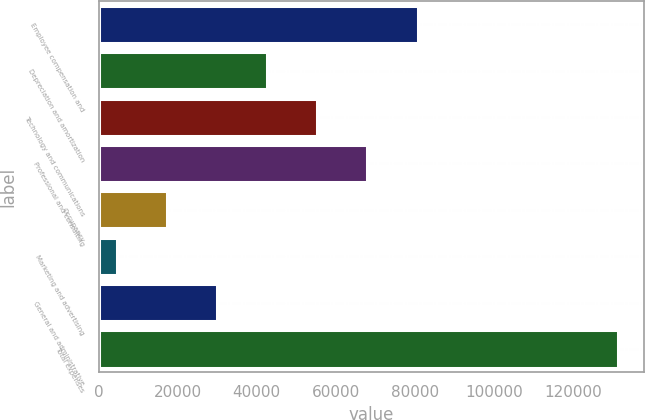<chart> <loc_0><loc_0><loc_500><loc_500><bar_chart><fcel>Employee compensation and<fcel>Depreciation and amortization<fcel>Technology and communications<fcel>Professional and consulting<fcel>Occupancy<fcel>Marketing and advertising<fcel>General and administrative<fcel>Total expenses<nl><fcel>80724.6<fcel>42678.3<fcel>55360.4<fcel>68042.5<fcel>17314.1<fcel>4632<fcel>29996.2<fcel>131453<nl></chart> 